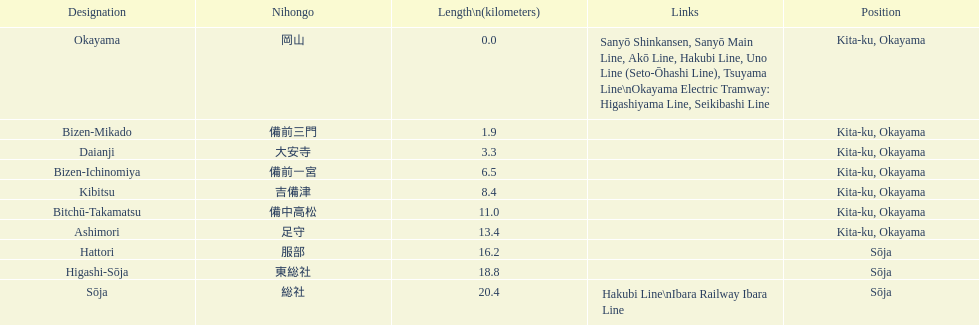How many stations have a distance below 15km? 7. 